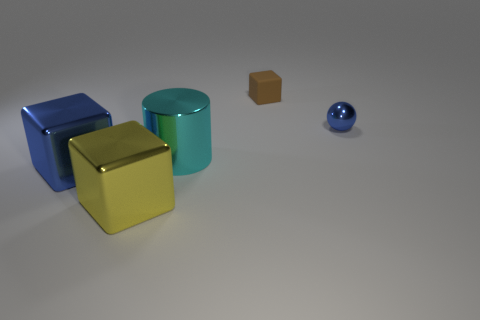Are there any yellow cubes that have the same material as the large yellow object?
Provide a short and direct response. No. There is another matte object that is the same shape as the large blue thing; what is its color?
Give a very brief answer. Brown. Is the small ball made of the same material as the cyan cylinder left of the brown thing?
Keep it short and to the point. Yes. The metallic object that is on the right side of the large object behind the blue metallic block is what shape?
Provide a short and direct response. Sphere. There is a blue thing in front of the blue sphere; is its size the same as the small blue metallic sphere?
Offer a very short reply. No. What number of other objects are there of the same shape as the small brown object?
Your answer should be very brief. 2. There is a shiny cube left of the yellow metal thing; is its color the same as the small shiny thing?
Provide a succinct answer. Yes. Is there another small metallic ball of the same color as the small ball?
Ensure brevity in your answer.  No. There is a blue ball; what number of large blue objects are in front of it?
Provide a succinct answer. 1. What number of other objects are there of the same size as the cyan cylinder?
Offer a terse response. 2. 